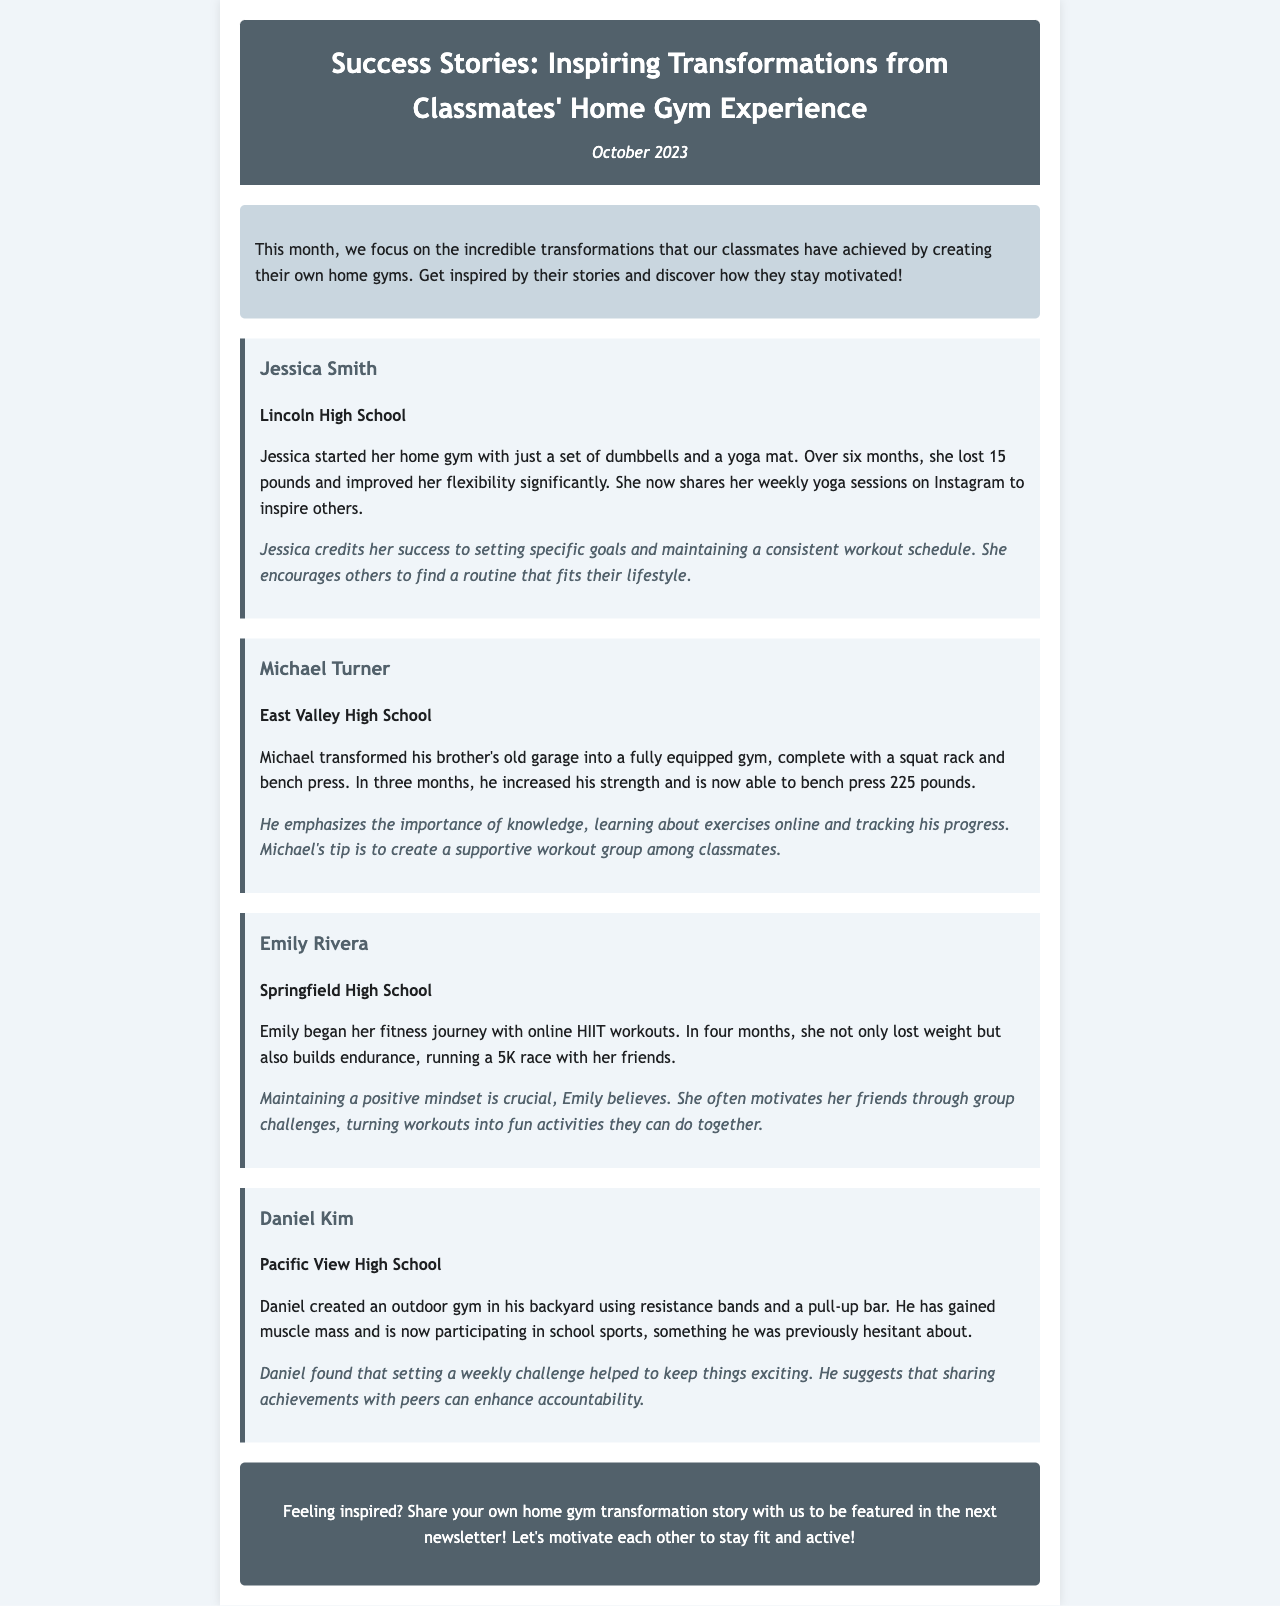What is the headline of the newsletter? The headline is the main title presented at the top of the newsletter, which summarizes its focus.
Answer: Success Stories: Inspiring Transformations from Classmates' Home Gym Experience Who is the first student featured in a success story? The first student mentioned in the success stories section of the newsletter is the one who began with dumbbells and a yoga mat.
Answer: Jessica Smith How much weight did Jessica lose? This question pertains to the specific accomplishment of the first featured student, focusing on a numerical goal achieved through her home gym efforts.
Answer: 15 pounds What type of workouts did Emily begin her journey with? This question seeks to identify the specific workout style that another student applied to start her fitness journey.
Answer: HIIT workouts Which school does Michael Turner attend? This question relates to which educational institution is associated with one of the featured success stories.
Answer: East Valley High School What piece of equipment did Daniel use for his outdoor gym? This question looks for specific exercise equipment mentioned in Daniel's transformation story.
Answer: Resistance bands What is one of Michael's tips for achieving fitness goals? This question requires the extraction of a motivational tip shared by Michael regarding fitness and progress tracking.
Answer: Create a supportive workout group What was a significant achievement of Emily on her fitness journey? This question pertains to the accomplishment that marks a major milestone for Emily in her journey, reflecting her progress and success.
Answer: Running a 5K race What action does the newsletter encourage at the end? This question focuses on the call-to-action presented in the newsletter that invites readers to participate.
Answer: Share your own home gym transformation story 